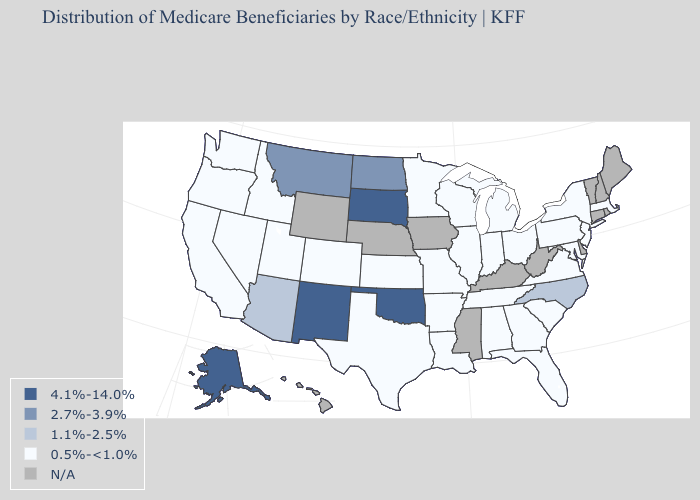Name the states that have a value in the range 1.1%-2.5%?
Give a very brief answer. Arizona, North Carolina. Does North Carolina have the highest value in the South?
Write a very short answer. No. Which states have the lowest value in the MidWest?
Write a very short answer. Illinois, Indiana, Kansas, Michigan, Minnesota, Missouri, Ohio, Wisconsin. What is the highest value in states that border Kentucky?
Concise answer only. 0.5%-<1.0%. What is the highest value in states that border Wyoming?
Keep it brief. 4.1%-14.0%. What is the value of New Jersey?
Answer briefly. 0.5%-<1.0%. Name the states that have a value in the range 1.1%-2.5%?
Concise answer only. Arizona, North Carolina. What is the lowest value in the USA?
Keep it brief. 0.5%-<1.0%. Does the first symbol in the legend represent the smallest category?
Concise answer only. No. Name the states that have a value in the range 0.5%-<1.0%?
Be succinct. Alabama, Arkansas, California, Colorado, Florida, Georgia, Idaho, Illinois, Indiana, Kansas, Louisiana, Maryland, Massachusetts, Michigan, Minnesota, Missouri, Nevada, New Jersey, New York, Ohio, Oregon, Pennsylvania, South Carolina, Tennessee, Texas, Utah, Virginia, Washington, Wisconsin. What is the value of Wyoming?
Be succinct. N/A. Which states have the lowest value in the USA?
Write a very short answer. Alabama, Arkansas, California, Colorado, Florida, Georgia, Idaho, Illinois, Indiana, Kansas, Louisiana, Maryland, Massachusetts, Michigan, Minnesota, Missouri, Nevada, New Jersey, New York, Ohio, Oregon, Pennsylvania, South Carolina, Tennessee, Texas, Utah, Virginia, Washington, Wisconsin. Is the legend a continuous bar?
Write a very short answer. No. Name the states that have a value in the range 0.5%-<1.0%?
Keep it brief. Alabama, Arkansas, California, Colorado, Florida, Georgia, Idaho, Illinois, Indiana, Kansas, Louisiana, Maryland, Massachusetts, Michigan, Minnesota, Missouri, Nevada, New Jersey, New York, Ohio, Oregon, Pennsylvania, South Carolina, Tennessee, Texas, Utah, Virginia, Washington, Wisconsin. 